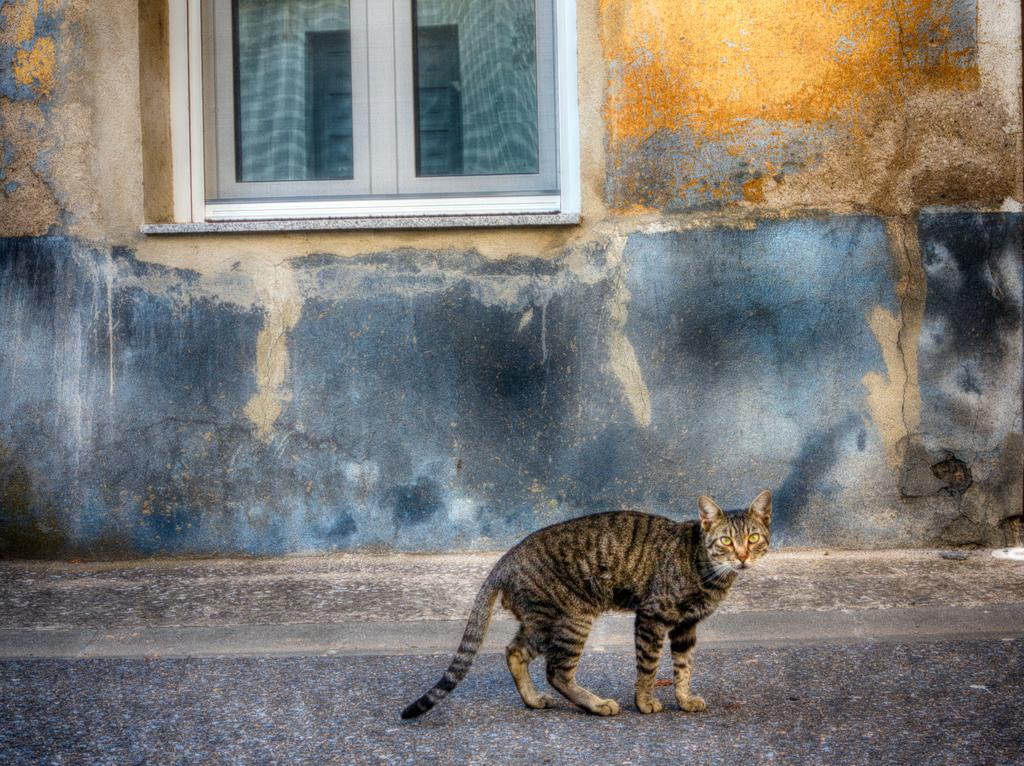What type of animal is present in the image? There is a cat in the image. Can you describe the appearance of the cat? The cat is black and ash colored. Where is the cat located in the image? The cat is on the road. What structures can be seen in the background of the image? There is a wall and a window visible in the image. What type of alarm can be heard going off in the image? There is no alarm present in the image, and therefore no sound can be heard. 